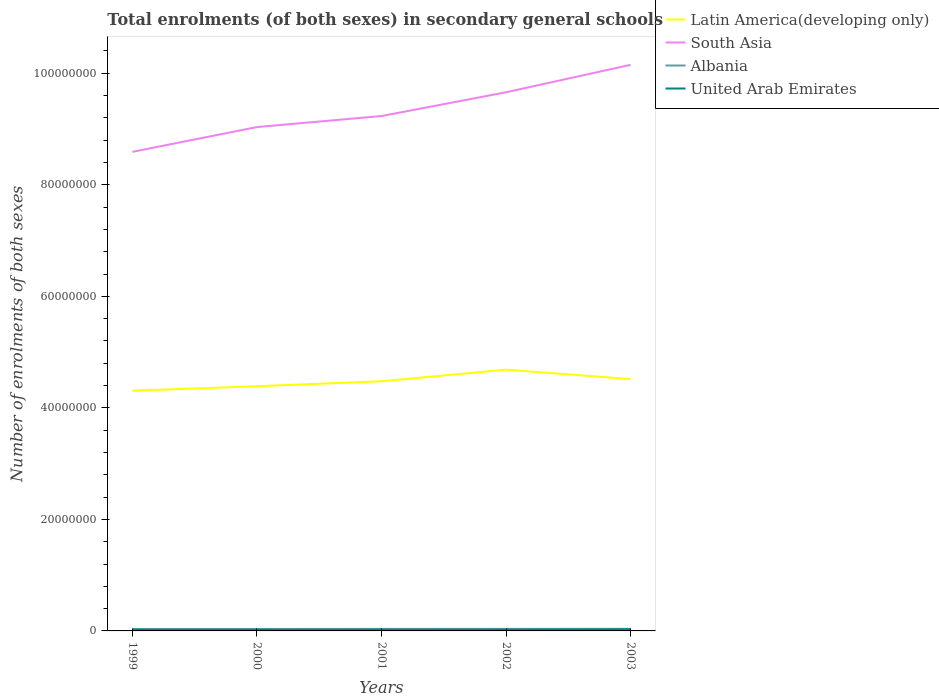How many different coloured lines are there?
Your response must be concise. 4. Across all years, what is the maximum number of enrolments in secondary schools in Albania?
Ensure brevity in your answer.  3.48e+05. In which year was the number of enrolments in secondary schools in United Arab Emirates maximum?
Keep it short and to the point. 1999. What is the total number of enrolments in secondary schools in South Asia in the graph?
Ensure brevity in your answer.  -9.18e+06. What is the difference between the highest and the second highest number of enrolments in secondary schools in South Asia?
Provide a short and direct response. 1.56e+07. Is the number of enrolments in secondary schools in South Asia strictly greater than the number of enrolments in secondary schools in Latin America(developing only) over the years?
Ensure brevity in your answer.  No. How many lines are there?
Offer a very short reply. 4. Does the graph contain any zero values?
Ensure brevity in your answer.  No. How many legend labels are there?
Your answer should be compact. 4. What is the title of the graph?
Give a very brief answer. Total enrolments (of both sexes) in secondary general schools. What is the label or title of the Y-axis?
Your answer should be compact. Number of enrolments of both sexes. What is the Number of enrolments of both sexes of Latin America(developing only) in 1999?
Offer a very short reply. 4.31e+07. What is the Number of enrolments of both sexes in South Asia in 1999?
Your answer should be compact. 8.59e+07. What is the Number of enrolments of both sexes of Albania in 1999?
Provide a short and direct response. 3.48e+05. What is the Number of enrolments of both sexes in United Arab Emirates in 1999?
Keep it short and to the point. 2.00e+05. What is the Number of enrolments of both sexes in Latin America(developing only) in 2000?
Give a very brief answer. 4.39e+07. What is the Number of enrolments of both sexes in South Asia in 2000?
Provide a short and direct response. 9.03e+07. What is the Number of enrolments of both sexes in Albania in 2000?
Ensure brevity in your answer.  3.51e+05. What is the Number of enrolments of both sexes in United Arab Emirates in 2000?
Offer a terse response. 2.08e+05. What is the Number of enrolments of both sexes in Latin America(developing only) in 2001?
Make the answer very short. 4.48e+07. What is the Number of enrolments of both sexes in South Asia in 2001?
Provide a short and direct response. 9.23e+07. What is the Number of enrolments of both sexes in Albania in 2001?
Your response must be concise. 3.62e+05. What is the Number of enrolments of both sexes in United Arab Emirates in 2001?
Give a very brief answer. 2.18e+05. What is the Number of enrolments of both sexes of Latin America(developing only) in 2002?
Ensure brevity in your answer.  4.69e+07. What is the Number of enrolments of both sexes in South Asia in 2002?
Give a very brief answer. 9.66e+07. What is the Number of enrolments of both sexes of Albania in 2002?
Offer a very short reply. 3.64e+05. What is the Number of enrolments of both sexes of United Arab Emirates in 2002?
Ensure brevity in your answer.  2.25e+05. What is the Number of enrolments of both sexes in Latin America(developing only) in 2003?
Offer a very short reply. 4.52e+07. What is the Number of enrolments of both sexes of South Asia in 2003?
Your answer should be very brief. 1.02e+08. What is the Number of enrolments of both sexes in Albania in 2003?
Your answer should be compact. 3.76e+05. What is the Number of enrolments of both sexes in United Arab Emirates in 2003?
Ensure brevity in your answer.  2.72e+05. Across all years, what is the maximum Number of enrolments of both sexes in Latin America(developing only)?
Keep it short and to the point. 4.69e+07. Across all years, what is the maximum Number of enrolments of both sexes in South Asia?
Your answer should be very brief. 1.02e+08. Across all years, what is the maximum Number of enrolments of both sexes in Albania?
Keep it short and to the point. 3.76e+05. Across all years, what is the maximum Number of enrolments of both sexes in United Arab Emirates?
Your answer should be compact. 2.72e+05. Across all years, what is the minimum Number of enrolments of both sexes of Latin America(developing only)?
Provide a succinct answer. 4.31e+07. Across all years, what is the minimum Number of enrolments of both sexes in South Asia?
Your answer should be very brief. 8.59e+07. Across all years, what is the minimum Number of enrolments of both sexes in Albania?
Provide a succinct answer. 3.48e+05. Across all years, what is the minimum Number of enrolments of both sexes in United Arab Emirates?
Offer a very short reply. 2.00e+05. What is the total Number of enrolments of both sexes in Latin America(developing only) in the graph?
Your answer should be compact. 2.24e+08. What is the total Number of enrolments of both sexes of South Asia in the graph?
Make the answer very short. 4.67e+08. What is the total Number of enrolments of both sexes of Albania in the graph?
Ensure brevity in your answer.  1.80e+06. What is the total Number of enrolments of both sexes of United Arab Emirates in the graph?
Make the answer very short. 1.12e+06. What is the difference between the Number of enrolments of both sexes in Latin America(developing only) in 1999 and that in 2000?
Offer a terse response. -7.99e+05. What is the difference between the Number of enrolments of both sexes in South Asia in 1999 and that in 2000?
Provide a short and direct response. -4.44e+06. What is the difference between the Number of enrolments of both sexes of Albania in 1999 and that in 2000?
Provide a succinct answer. -2794. What is the difference between the Number of enrolments of both sexes in United Arab Emirates in 1999 and that in 2000?
Your answer should be very brief. -8539. What is the difference between the Number of enrolments of both sexes of Latin America(developing only) in 1999 and that in 2001?
Your response must be concise. -1.69e+06. What is the difference between the Number of enrolments of both sexes in South Asia in 1999 and that in 2001?
Make the answer very short. -6.42e+06. What is the difference between the Number of enrolments of both sexes of Albania in 1999 and that in 2001?
Keep it short and to the point. -1.32e+04. What is the difference between the Number of enrolments of both sexes in United Arab Emirates in 1999 and that in 2001?
Offer a terse response. -1.87e+04. What is the difference between the Number of enrolments of both sexes in Latin America(developing only) in 1999 and that in 2002?
Your answer should be very brief. -3.77e+06. What is the difference between the Number of enrolments of both sexes of South Asia in 1999 and that in 2002?
Offer a terse response. -1.07e+07. What is the difference between the Number of enrolments of both sexes of Albania in 1999 and that in 2002?
Provide a succinct answer. -1.53e+04. What is the difference between the Number of enrolments of both sexes of United Arab Emirates in 1999 and that in 2002?
Your answer should be compact. -2.50e+04. What is the difference between the Number of enrolments of both sexes of Latin America(developing only) in 1999 and that in 2003?
Provide a succinct answer. -2.08e+06. What is the difference between the Number of enrolments of both sexes of South Asia in 1999 and that in 2003?
Provide a short and direct response. -1.56e+07. What is the difference between the Number of enrolments of both sexes of Albania in 1999 and that in 2003?
Provide a succinct answer. -2.74e+04. What is the difference between the Number of enrolments of both sexes of United Arab Emirates in 1999 and that in 2003?
Make the answer very short. -7.20e+04. What is the difference between the Number of enrolments of both sexes of Latin America(developing only) in 2000 and that in 2001?
Offer a terse response. -8.90e+05. What is the difference between the Number of enrolments of both sexes of South Asia in 2000 and that in 2001?
Provide a succinct answer. -1.98e+06. What is the difference between the Number of enrolments of both sexes of Albania in 2000 and that in 2001?
Provide a short and direct response. -1.04e+04. What is the difference between the Number of enrolments of both sexes of United Arab Emirates in 2000 and that in 2001?
Ensure brevity in your answer.  -1.02e+04. What is the difference between the Number of enrolments of both sexes of Latin America(developing only) in 2000 and that in 2002?
Keep it short and to the point. -2.97e+06. What is the difference between the Number of enrolments of both sexes in South Asia in 2000 and that in 2002?
Give a very brief answer. -6.24e+06. What is the difference between the Number of enrolments of both sexes of Albania in 2000 and that in 2002?
Offer a very short reply. -1.25e+04. What is the difference between the Number of enrolments of both sexes in United Arab Emirates in 2000 and that in 2002?
Your answer should be compact. -1.65e+04. What is the difference between the Number of enrolments of both sexes of Latin America(developing only) in 2000 and that in 2003?
Provide a succinct answer. -1.28e+06. What is the difference between the Number of enrolments of both sexes in South Asia in 2000 and that in 2003?
Your answer should be very brief. -1.12e+07. What is the difference between the Number of enrolments of both sexes of Albania in 2000 and that in 2003?
Provide a succinct answer. -2.46e+04. What is the difference between the Number of enrolments of both sexes of United Arab Emirates in 2000 and that in 2003?
Ensure brevity in your answer.  -6.35e+04. What is the difference between the Number of enrolments of both sexes in Latin America(developing only) in 2001 and that in 2002?
Your answer should be compact. -2.08e+06. What is the difference between the Number of enrolments of both sexes of South Asia in 2001 and that in 2002?
Your answer should be compact. -4.26e+06. What is the difference between the Number of enrolments of both sexes of Albania in 2001 and that in 2002?
Offer a very short reply. -2161. What is the difference between the Number of enrolments of both sexes in United Arab Emirates in 2001 and that in 2002?
Your response must be concise. -6265. What is the difference between the Number of enrolments of both sexes in Latin America(developing only) in 2001 and that in 2003?
Keep it short and to the point. -3.90e+05. What is the difference between the Number of enrolments of both sexes in South Asia in 2001 and that in 2003?
Provide a succinct answer. -9.18e+06. What is the difference between the Number of enrolments of both sexes in Albania in 2001 and that in 2003?
Make the answer very short. -1.43e+04. What is the difference between the Number of enrolments of both sexes of United Arab Emirates in 2001 and that in 2003?
Your response must be concise. -5.33e+04. What is the difference between the Number of enrolments of both sexes in Latin America(developing only) in 2002 and that in 2003?
Give a very brief answer. 1.69e+06. What is the difference between the Number of enrolments of both sexes in South Asia in 2002 and that in 2003?
Ensure brevity in your answer.  -4.92e+06. What is the difference between the Number of enrolments of both sexes of Albania in 2002 and that in 2003?
Ensure brevity in your answer.  -1.21e+04. What is the difference between the Number of enrolments of both sexes of United Arab Emirates in 2002 and that in 2003?
Ensure brevity in your answer.  -4.70e+04. What is the difference between the Number of enrolments of both sexes of Latin America(developing only) in 1999 and the Number of enrolments of both sexes of South Asia in 2000?
Your response must be concise. -4.73e+07. What is the difference between the Number of enrolments of both sexes in Latin America(developing only) in 1999 and the Number of enrolments of both sexes in Albania in 2000?
Your response must be concise. 4.27e+07. What is the difference between the Number of enrolments of both sexes in Latin America(developing only) in 1999 and the Number of enrolments of both sexes in United Arab Emirates in 2000?
Your answer should be very brief. 4.29e+07. What is the difference between the Number of enrolments of both sexes in South Asia in 1999 and the Number of enrolments of both sexes in Albania in 2000?
Provide a short and direct response. 8.56e+07. What is the difference between the Number of enrolments of both sexes of South Asia in 1999 and the Number of enrolments of both sexes of United Arab Emirates in 2000?
Your answer should be very brief. 8.57e+07. What is the difference between the Number of enrolments of both sexes in Albania in 1999 and the Number of enrolments of both sexes in United Arab Emirates in 2000?
Give a very brief answer. 1.40e+05. What is the difference between the Number of enrolments of both sexes of Latin America(developing only) in 1999 and the Number of enrolments of both sexes of South Asia in 2001?
Your answer should be compact. -4.92e+07. What is the difference between the Number of enrolments of both sexes in Latin America(developing only) in 1999 and the Number of enrolments of both sexes in Albania in 2001?
Provide a succinct answer. 4.27e+07. What is the difference between the Number of enrolments of both sexes of Latin America(developing only) in 1999 and the Number of enrolments of both sexes of United Arab Emirates in 2001?
Make the answer very short. 4.29e+07. What is the difference between the Number of enrolments of both sexes in South Asia in 1999 and the Number of enrolments of both sexes in Albania in 2001?
Keep it short and to the point. 8.55e+07. What is the difference between the Number of enrolments of both sexes in South Asia in 1999 and the Number of enrolments of both sexes in United Arab Emirates in 2001?
Your response must be concise. 8.57e+07. What is the difference between the Number of enrolments of both sexes in Albania in 1999 and the Number of enrolments of both sexes in United Arab Emirates in 2001?
Your response must be concise. 1.30e+05. What is the difference between the Number of enrolments of both sexes in Latin America(developing only) in 1999 and the Number of enrolments of both sexes in South Asia in 2002?
Provide a succinct answer. -5.35e+07. What is the difference between the Number of enrolments of both sexes of Latin America(developing only) in 1999 and the Number of enrolments of both sexes of Albania in 2002?
Make the answer very short. 4.27e+07. What is the difference between the Number of enrolments of both sexes of Latin America(developing only) in 1999 and the Number of enrolments of both sexes of United Arab Emirates in 2002?
Give a very brief answer. 4.29e+07. What is the difference between the Number of enrolments of both sexes of South Asia in 1999 and the Number of enrolments of both sexes of Albania in 2002?
Give a very brief answer. 8.55e+07. What is the difference between the Number of enrolments of both sexes of South Asia in 1999 and the Number of enrolments of both sexes of United Arab Emirates in 2002?
Ensure brevity in your answer.  8.57e+07. What is the difference between the Number of enrolments of both sexes of Albania in 1999 and the Number of enrolments of both sexes of United Arab Emirates in 2002?
Ensure brevity in your answer.  1.24e+05. What is the difference between the Number of enrolments of both sexes of Latin America(developing only) in 1999 and the Number of enrolments of both sexes of South Asia in 2003?
Your answer should be very brief. -5.84e+07. What is the difference between the Number of enrolments of both sexes of Latin America(developing only) in 1999 and the Number of enrolments of both sexes of Albania in 2003?
Your answer should be very brief. 4.27e+07. What is the difference between the Number of enrolments of both sexes of Latin America(developing only) in 1999 and the Number of enrolments of both sexes of United Arab Emirates in 2003?
Make the answer very short. 4.28e+07. What is the difference between the Number of enrolments of both sexes in South Asia in 1999 and the Number of enrolments of both sexes in Albania in 2003?
Offer a terse response. 8.55e+07. What is the difference between the Number of enrolments of both sexes in South Asia in 1999 and the Number of enrolments of both sexes in United Arab Emirates in 2003?
Offer a terse response. 8.56e+07. What is the difference between the Number of enrolments of both sexes in Albania in 1999 and the Number of enrolments of both sexes in United Arab Emirates in 2003?
Make the answer very short. 7.66e+04. What is the difference between the Number of enrolments of both sexes in Latin America(developing only) in 2000 and the Number of enrolments of both sexes in South Asia in 2001?
Give a very brief answer. -4.85e+07. What is the difference between the Number of enrolments of both sexes in Latin America(developing only) in 2000 and the Number of enrolments of both sexes in Albania in 2001?
Offer a very short reply. 4.35e+07. What is the difference between the Number of enrolments of both sexes in Latin America(developing only) in 2000 and the Number of enrolments of both sexes in United Arab Emirates in 2001?
Your answer should be very brief. 4.37e+07. What is the difference between the Number of enrolments of both sexes in South Asia in 2000 and the Number of enrolments of both sexes in Albania in 2001?
Keep it short and to the point. 9.00e+07. What is the difference between the Number of enrolments of both sexes of South Asia in 2000 and the Number of enrolments of both sexes of United Arab Emirates in 2001?
Keep it short and to the point. 9.01e+07. What is the difference between the Number of enrolments of both sexes of Albania in 2000 and the Number of enrolments of both sexes of United Arab Emirates in 2001?
Keep it short and to the point. 1.33e+05. What is the difference between the Number of enrolments of both sexes of Latin America(developing only) in 2000 and the Number of enrolments of both sexes of South Asia in 2002?
Ensure brevity in your answer.  -5.27e+07. What is the difference between the Number of enrolments of both sexes in Latin America(developing only) in 2000 and the Number of enrolments of both sexes in Albania in 2002?
Offer a very short reply. 4.35e+07. What is the difference between the Number of enrolments of both sexes in Latin America(developing only) in 2000 and the Number of enrolments of both sexes in United Arab Emirates in 2002?
Ensure brevity in your answer.  4.37e+07. What is the difference between the Number of enrolments of both sexes in South Asia in 2000 and the Number of enrolments of both sexes in Albania in 2002?
Ensure brevity in your answer.  9.00e+07. What is the difference between the Number of enrolments of both sexes of South Asia in 2000 and the Number of enrolments of both sexes of United Arab Emirates in 2002?
Provide a short and direct response. 9.01e+07. What is the difference between the Number of enrolments of both sexes of Albania in 2000 and the Number of enrolments of both sexes of United Arab Emirates in 2002?
Provide a short and direct response. 1.26e+05. What is the difference between the Number of enrolments of both sexes of Latin America(developing only) in 2000 and the Number of enrolments of both sexes of South Asia in 2003?
Your answer should be compact. -5.76e+07. What is the difference between the Number of enrolments of both sexes of Latin America(developing only) in 2000 and the Number of enrolments of both sexes of Albania in 2003?
Your answer should be compact. 4.35e+07. What is the difference between the Number of enrolments of both sexes of Latin America(developing only) in 2000 and the Number of enrolments of both sexes of United Arab Emirates in 2003?
Keep it short and to the point. 4.36e+07. What is the difference between the Number of enrolments of both sexes in South Asia in 2000 and the Number of enrolments of both sexes in Albania in 2003?
Give a very brief answer. 9.00e+07. What is the difference between the Number of enrolments of both sexes in South Asia in 2000 and the Number of enrolments of both sexes in United Arab Emirates in 2003?
Provide a succinct answer. 9.01e+07. What is the difference between the Number of enrolments of both sexes in Albania in 2000 and the Number of enrolments of both sexes in United Arab Emirates in 2003?
Give a very brief answer. 7.94e+04. What is the difference between the Number of enrolments of both sexes in Latin America(developing only) in 2001 and the Number of enrolments of both sexes in South Asia in 2002?
Keep it short and to the point. -5.18e+07. What is the difference between the Number of enrolments of both sexes in Latin America(developing only) in 2001 and the Number of enrolments of both sexes in Albania in 2002?
Make the answer very short. 4.44e+07. What is the difference between the Number of enrolments of both sexes of Latin America(developing only) in 2001 and the Number of enrolments of both sexes of United Arab Emirates in 2002?
Ensure brevity in your answer.  4.45e+07. What is the difference between the Number of enrolments of both sexes of South Asia in 2001 and the Number of enrolments of both sexes of Albania in 2002?
Your answer should be very brief. 9.20e+07. What is the difference between the Number of enrolments of both sexes in South Asia in 2001 and the Number of enrolments of both sexes in United Arab Emirates in 2002?
Your answer should be very brief. 9.21e+07. What is the difference between the Number of enrolments of both sexes in Albania in 2001 and the Number of enrolments of both sexes in United Arab Emirates in 2002?
Provide a succinct answer. 1.37e+05. What is the difference between the Number of enrolments of both sexes of Latin America(developing only) in 2001 and the Number of enrolments of both sexes of South Asia in 2003?
Offer a terse response. -5.67e+07. What is the difference between the Number of enrolments of both sexes of Latin America(developing only) in 2001 and the Number of enrolments of both sexes of Albania in 2003?
Provide a short and direct response. 4.44e+07. What is the difference between the Number of enrolments of both sexes of Latin America(developing only) in 2001 and the Number of enrolments of both sexes of United Arab Emirates in 2003?
Offer a terse response. 4.45e+07. What is the difference between the Number of enrolments of both sexes in South Asia in 2001 and the Number of enrolments of both sexes in Albania in 2003?
Offer a very short reply. 9.20e+07. What is the difference between the Number of enrolments of both sexes in South Asia in 2001 and the Number of enrolments of both sexes in United Arab Emirates in 2003?
Provide a short and direct response. 9.21e+07. What is the difference between the Number of enrolments of both sexes of Albania in 2001 and the Number of enrolments of both sexes of United Arab Emirates in 2003?
Offer a terse response. 8.98e+04. What is the difference between the Number of enrolments of both sexes in Latin America(developing only) in 2002 and the Number of enrolments of both sexes in South Asia in 2003?
Your response must be concise. -5.47e+07. What is the difference between the Number of enrolments of both sexes in Latin America(developing only) in 2002 and the Number of enrolments of both sexes in Albania in 2003?
Provide a succinct answer. 4.65e+07. What is the difference between the Number of enrolments of both sexes of Latin America(developing only) in 2002 and the Number of enrolments of both sexes of United Arab Emirates in 2003?
Offer a terse response. 4.66e+07. What is the difference between the Number of enrolments of both sexes of South Asia in 2002 and the Number of enrolments of both sexes of Albania in 2003?
Make the answer very short. 9.62e+07. What is the difference between the Number of enrolments of both sexes of South Asia in 2002 and the Number of enrolments of both sexes of United Arab Emirates in 2003?
Your answer should be compact. 9.63e+07. What is the difference between the Number of enrolments of both sexes in Albania in 2002 and the Number of enrolments of both sexes in United Arab Emirates in 2003?
Your answer should be very brief. 9.19e+04. What is the average Number of enrolments of both sexes in Latin America(developing only) per year?
Offer a terse response. 4.47e+07. What is the average Number of enrolments of both sexes of South Asia per year?
Give a very brief answer. 9.33e+07. What is the average Number of enrolments of both sexes of Albania per year?
Make the answer very short. 3.60e+05. What is the average Number of enrolments of both sexes of United Arab Emirates per year?
Provide a short and direct response. 2.25e+05. In the year 1999, what is the difference between the Number of enrolments of both sexes of Latin America(developing only) and Number of enrolments of both sexes of South Asia?
Your response must be concise. -4.28e+07. In the year 1999, what is the difference between the Number of enrolments of both sexes in Latin America(developing only) and Number of enrolments of both sexes in Albania?
Offer a very short reply. 4.27e+07. In the year 1999, what is the difference between the Number of enrolments of both sexes of Latin America(developing only) and Number of enrolments of both sexes of United Arab Emirates?
Your answer should be compact. 4.29e+07. In the year 1999, what is the difference between the Number of enrolments of both sexes in South Asia and Number of enrolments of both sexes in Albania?
Provide a succinct answer. 8.56e+07. In the year 1999, what is the difference between the Number of enrolments of both sexes in South Asia and Number of enrolments of both sexes in United Arab Emirates?
Offer a very short reply. 8.57e+07. In the year 1999, what is the difference between the Number of enrolments of both sexes of Albania and Number of enrolments of both sexes of United Arab Emirates?
Offer a terse response. 1.49e+05. In the year 2000, what is the difference between the Number of enrolments of both sexes in Latin America(developing only) and Number of enrolments of both sexes in South Asia?
Offer a very short reply. -4.65e+07. In the year 2000, what is the difference between the Number of enrolments of both sexes of Latin America(developing only) and Number of enrolments of both sexes of Albania?
Ensure brevity in your answer.  4.35e+07. In the year 2000, what is the difference between the Number of enrolments of both sexes of Latin America(developing only) and Number of enrolments of both sexes of United Arab Emirates?
Offer a terse response. 4.37e+07. In the year 2000, what is the difference between the Number of enrolments of both sexes of South Asia and Number of enrolments of both sexes of Albania?
Your answer should be compact. 9.00e+07. In the year 2000, what is the difference between the Number of enrolments of both sexes of South Asia and Number of enrolments of both sexes of United Arab Emirates?
Ensure brevity in your answer.  9.01e+07. In the year 2000, what is the difference between the Number of enrolments of both sexes in Albania and Number of enrolments of both sexes in United Arab Emirates?
Provide a succinct answer. 1.43e+05. In the year 2001, what is the difference between the Number of enrolments of both sexes in Latin America(developing only) and Number of enrolments of both sexes in South Asia?
Your answer should be compact. -4.76e+07. In the year 2001, what is the difference between the Number of enrolments of both sexes in Latin America(developing only) and Number of enrolments of both sexes in Albania?
Keep it short and to the point. 4.44e+07. In the year 2001, what is the difference between the Number of enrolments of both sexes of Latin America(developing only) and Number of enrolments of both sexes of United Arab Emirates?
Offer a very short reply. 4.45e+07. In the year 2001, what is the difference between the Number of enrolments of both sexes in South Asia and Number of enrolments of both sexes in Albania?
Your response must be concise. 9.20e+07. In the year 2001, what is the difference between the Number of enrolments of both sexes in South Asia and Number of enrolments of both sexes in United Arab Emirates?
Your answer should be very brief. 9.21e+07. In the year 2001, what is the difference between the Number of enrolments of both sexes in Albania and Number of enrolments of both sexes in United Arab Emirates?
Ensure brevity in your answer.  1.43e+05. In the year 2002, what is the difference between the Number of enrolments of both sexes in Latin America(developing only) and Number of enrolments of both sexes in South Asia?
Ensure brevity in your answer.  -4.97e+07. In the year 2002, what is the difference between the Number of enrolments of both sexes of Latin America(developing only) and Number of enrolments of both sexes of Albania?
Provide a succinct answer. 4.65e+07. In the year 2002, what is the difference between the Number of enrolments of both sexes in Latin America(developing only) and Number of enrolments of both sexes in United Arab Emirates?
Keep it short and to the point. 4.66e+07. In the year 2002, what is the difference between the Number of enrolments of both sexes in South Asia and Number of enrolments of both sexes in Albania?
Your response must be concise. 9.62e+07. In the year 2002, what is the difference between the Number of enrolments of both sexes of South Asia and Number of enrolments of both sexes of United Arab Emirates?
Provide a succinct answer. 9.64e+07. In the year 2002, what is the difference between the Number of enrolments of both sexes of Albania and Number of enrolments of both sexes of United Arab Emirates?
Offer a very short reply. 1.39e+05. In the year 2003, what is the difference between the Number of enrolments of both sexes of Latin America(developing only) and Number of enrolments of both sexes of South Asia?
Offer a terse response. -5.64e+07. In the year 2003, what is the difference between the Number of enrolments of both sexes of Latin America(developing only) and Number of enrolments of both sexes of Albania?
Ensure brevity in your answer.  4.48e+07. In the year 2003, what is the difference between the Number of enrolments of both sexes in Latin America(developing only) and Number of enrolments of both sexes in United Arab Emirates?
Offer a terse response. 4.49e+07. In the year 2003, what is the difference between the Number of enrolments of both sexes of South Asia and Number of enrolments of both sexes of Albania?
Provide a succinct answer. 1.01e+08. In the year 2003, what is the difference between the Number of enrolments of both sexes in South Asia and Number of enrolments of both sexes in United Arab Emirates?
Keep it short and to the point. 1.01e+08. In the year 2003, what is the difference between the Number of enrolments of both sexes in Albania and Number of enrolments of both sexes in United Arab Emirates?
Keep it short and to the point. 1.04e+05. What is the ratio of the Number of enrolments of both sexes in Latin America(developing only) in 1999 to that in 2000?
Your answer should be very brief. 0.98. What is the ratio of the Number of enrolments of both sexes in South Asia in 1999 to that in 2000?
Give a very brief answer. 0.95. What is the ratio of the Number of enrolments of both sexes of Albania in 1999 to that in 2000?
Provide a short and direct response. 0.99. What is the ratio of the Number of enrolments of both sexes of Latin America(developing only) in 1999 to that in 2001?
Give a very brief answer. 0.96. What is the ratio of the Number of enrolments of both sexes of South Asia in 1999 to that in 2001?
Offer a very short reply. 0.93. What is the ratio of the Number of enrolments of both sexes of Albania in 1999 to that in 2001?
Keep it short and to the point. 0.96. What is the ratio of the Number of enrolments of both sexes of United Arab Emirates in 1999 to that in 2001?
Offer a very short reply. 0.91. What is the ratio of the Number of enrolments of both sexes of Latin America(developing only) in 1999 to that in 2002?
Give a very brief answer. 0.92. What is the ratio of the Number of enrolments of both sexes in South Asia in 1999 to that in 2002?
Offer a terse response. 0.89. What is the ratio of the Number of enrolments of both sexes of Albania in 1999 to that in 2002?
Make the answer very short. 0.96. What is the ratio of the Number of enrolments of both sexes in United Arab Emirates in 1999 to that in 2002?
Offer a terse response. 0.89. What is the ratio of the Number of enrolments of both sexes in Latin America(developing only) in 1999 to that in 2003?
Offer a very short reply. 0.95. What is the ratio of the Number of enrolments of both sexes in South Asia in 1999 to that in 2003?
Offer a terse response. 0.85. What is the ratio of the Number of enrolments of both sexes in Albania in 1999 to that in 2003?
Provide a short and direct response. 0.93. What is the ratio of the Number of enrolments of both sexes of United Arab Emirates in 1999 to that in 2003?
Ensure brevity in your answer.  0.73. What is the ratio of the Number of enrolments of both sexes in Latin America(developing only) in 2000 to that in 2001?
Make the answer very short. 0.98. What is the ratio of the Number of enrolments of both sexes of South Asia in 2000 to that in 2001?
Make the answer very short. 0.98. What is the ratio of the Number of enrolments of both sexes of Albania in 2000 to that in 2001?
Offer a very short reply. 0.97. What is the ratio of the Number of enrolments of both sexes of United Arab Emirates in 2000 to that in 2001?
Your response must be concise. 0.95. What is the ratio of the Number of enrolments of both sexes of Latin America(developing only) in 2000 to that in 2002?
Your answer should be very brief. 0.94. What is the ratio of the Number of enrolments of both sexes of South Asia in 2000 to that in 2002?
Give a very brief answer. 0.94. What is the ratio of the Number of enrolments of both sexes in Albania in 2000 to that in 2002?
Make the answer very short. 0.97. What is the ratio of the Number of enrolments of both sexes of United Arab Emirates in 2000 to that in 2002?
Ensure brevity in your answer.  0.93. What is the ratio of the Number of enrolments of both sexes of Latin America(developing only) in 2000 to that in 2003?
Give a very brief answer. 0.97. What is the ratio of the Number of enrolments of both sexes of South Asia in 2000 to that in 2003?
Your response must be concise. 0.89. What is the ratio of the Number of enrolments of both sexes in Albania in 2000 to that in 2003?
Ensure brevity in your answer.  0.93. What is the ratio of the Number of enrolments of both sexes in United Arab Emirates in 2000 to that in 2003?
Give a very brief answer. 0.77. What is the ratio of the Number of enrolments of both sexes of Latin America(developing only) in 2001 to that in 2002?
Offer a terse response. 0.96. What is the ratio of the Number of enrolments of both sexes in South Asia in 2001 to that in 2002?
Provide a short and direct response. 0.96. What is the ratio of the Number of enrolments of both sexes of Albania in 2001 to that in 2002?
Your answer should be compact. 0.99. What is the ratio of the Number of enrolments of both sexes of United Arab Emirates in 2001 to that in 2002?
Give a very brief answer. 0.97. What is the ratio of the Number of enrolments of both sexes in South Asia in 2001 to that in 2003?
Your answer should be very brief. 0.91. What is the ratio of the Number of enrolments of both sexes in Albania in 2001 to that in 2003?
Provide a short and direct response. 0.96. What is the ratio of the Number of enrolments of both sexes of United Arab Emirates in 2001 to that in 2003?
Make the answer very short. 0.8. What is the ratio of the Number of enrolments of both sexes of Latin America(developing only) in 2002 to that in 2003?
Offer a very short reply. 1.04. What is the ratio of the Number of enrolments of both sexes in South Asia in 2002 to that in 2003?
Your response must be concise. 0.95. What is the ratio of the Number of enrolments of both sexes of Albania in 2002 to that in 2003?
Make the answer very short. 0.97. What is the ratio of the Number of enrolments of both sexes of United Arab Emirates in 2002 to that in 2003?
Ensure brevity in your answer.  0.83. What is the difference between the highest and the second highest Number of enrolments of both sexes of Latin America(developing only)?
Make the answer very short. 1.69e+06. What is the difference between the highest and the second highest Number of enrolments of both sexes in South Asia?
Make the answer very short. 4.92e+06. What is the difference between the highest and the second highest Number of enrolments of both sexes of Albania?
Your answer should be very brief. 1.21e+04. What is the difference between the highest and the second highest Number of enrolments of both sexes of United Arab Emirates?
Provide a short and direct response. 4.70e+04. What is the difference between the highest and the lowest Number of enrolments of both sexes in Latin America(developing only)?
Offer a terse response. 3.77e+06. What is the difference between the highest and the lowest Number of enrolments of both sexes of South Asia?
Provide a short and direct response. 1.56e+07. What is the difference between the highest and the lowest Number of enrolments of both sexes of Albania?
Give a very brief answer. 2.74e+04. What is the difference between the highest and the lowest Number of enrolments of both sexes in United Arab Emirates?
Your response must be concise. 7.20e+04. 